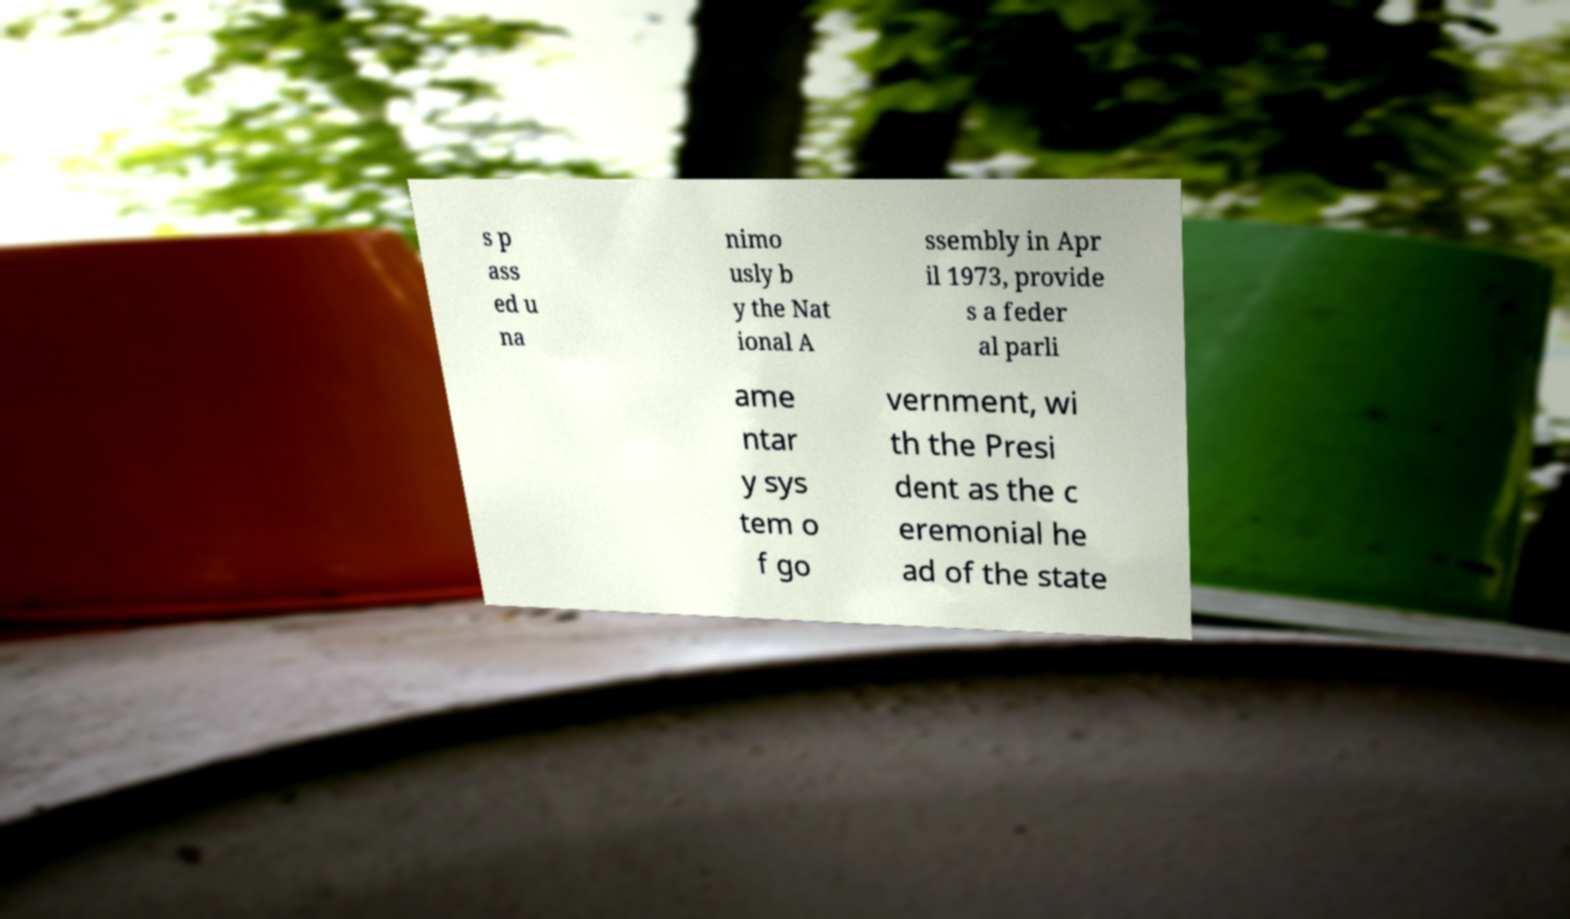Can you accurately transcribe the text from the provided image for me? s p ass ed u na nimo usly b y the Nat ional A ssembly in Apr il 1973, provide s a feder al parli ame ntar y sys tem o f go vernment, wi th the Presi dent as the c eremonial he ad of the state 